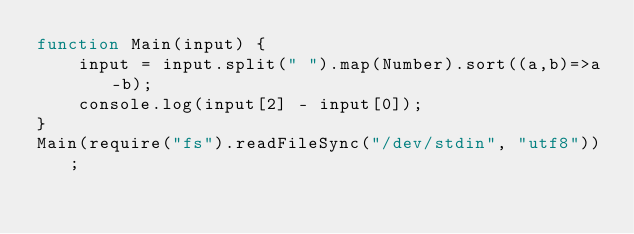<code> <loc_0><loc_0><loc_500><loc_500><_JavaScript_>function Main(input) {
    input = input.split(" ").map(Number).sort((a,b)=>a-b);
    console.log(input[2] - input[0]);
}
Main(require("fs").readFileSync("/dev/stdin", "utf8"));</code> 